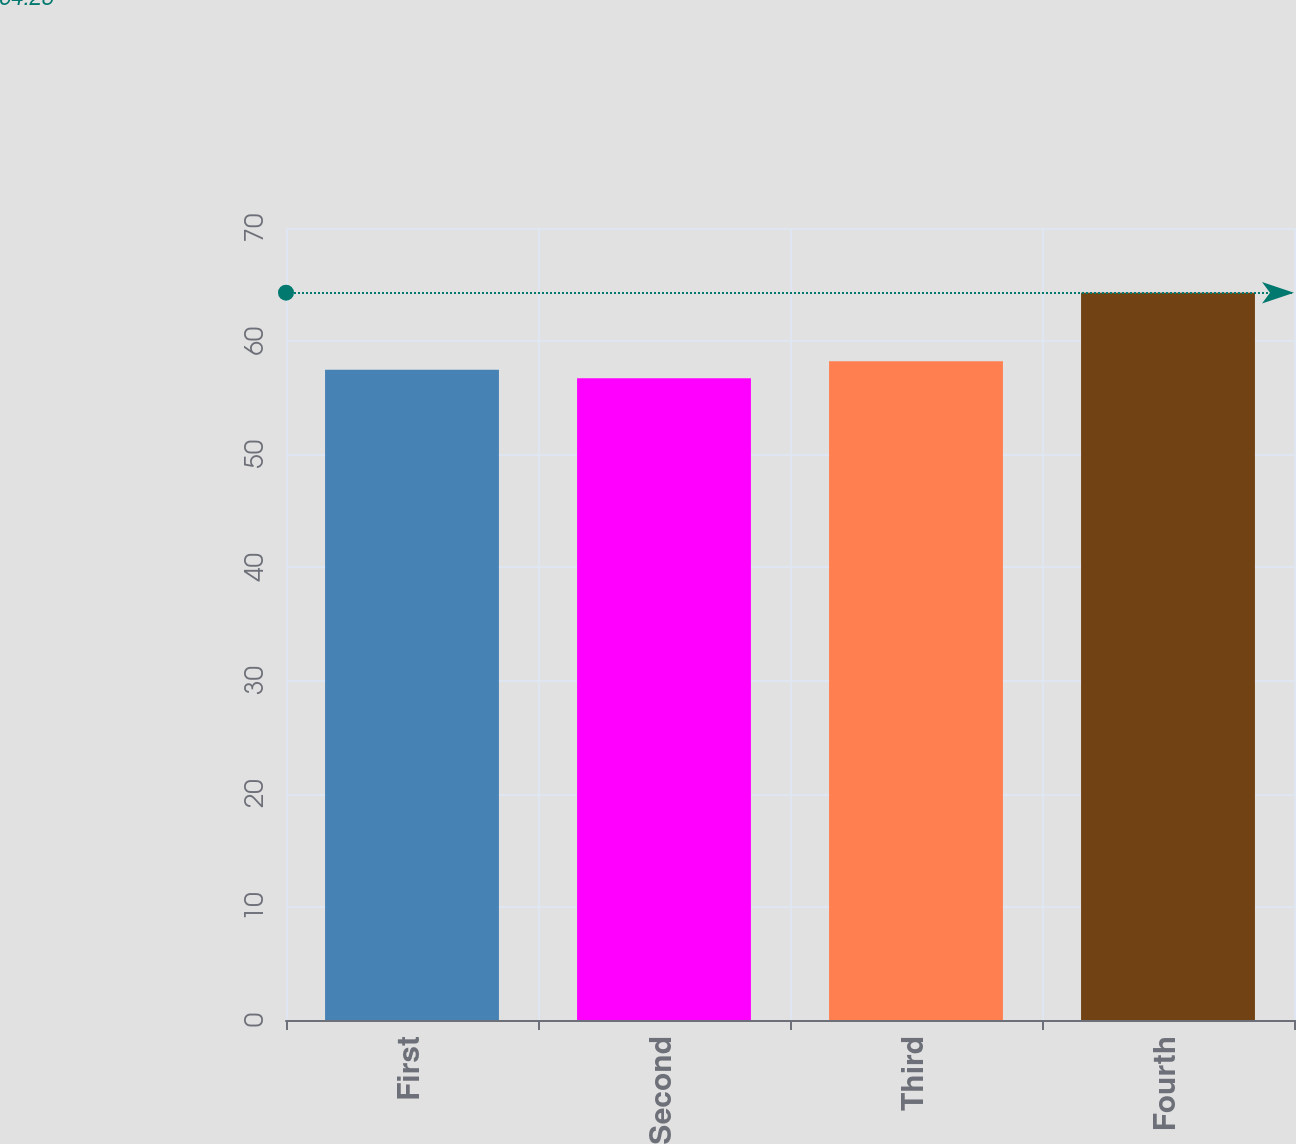Convert chart. <chart><loc_0><loc_0><loc_500><loc_500><bar_chart><fcel>First<fcel>Second<fcel>Third<fcel>Fourth<nl><fcel>57.48<fcel>56.73<fcel>58.23<fcel>64.28<nl></chart> 